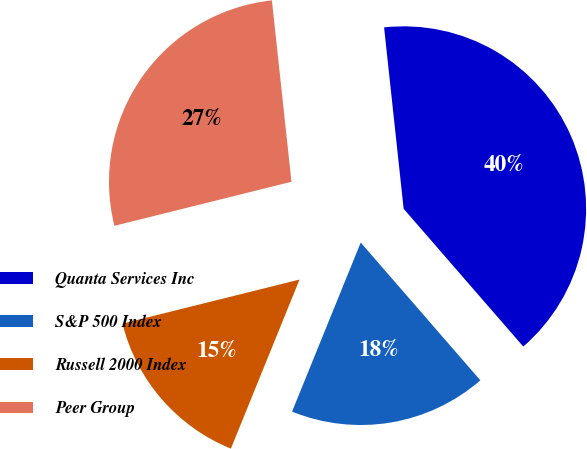<chart> <loc_0><loc_0><loc_500><loc_500><pie_chart><fcel>Quanta Services Inc<fcel>S&P 500 Index<fcel>Russell 2000 Index<fcel>Peer Group<nl><fcel>40.33%<fcel>17.52%<fcel>14.98%<fcel>27.17%<nl></chart> 